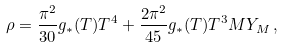Convert formula to latex. <formula><loc_0><loc_0><loc_500><loc_500>\rho = \frac { \pi ^ { 2 } } { 3 0 } g _ { * } ( T ) T ^ { 4 } + \frac { 2 \pi ^ { 2 } } { 4 5 } g _ { * } ( T ) T ^ { 3 } M Y _ { M } \, ,</formula> 